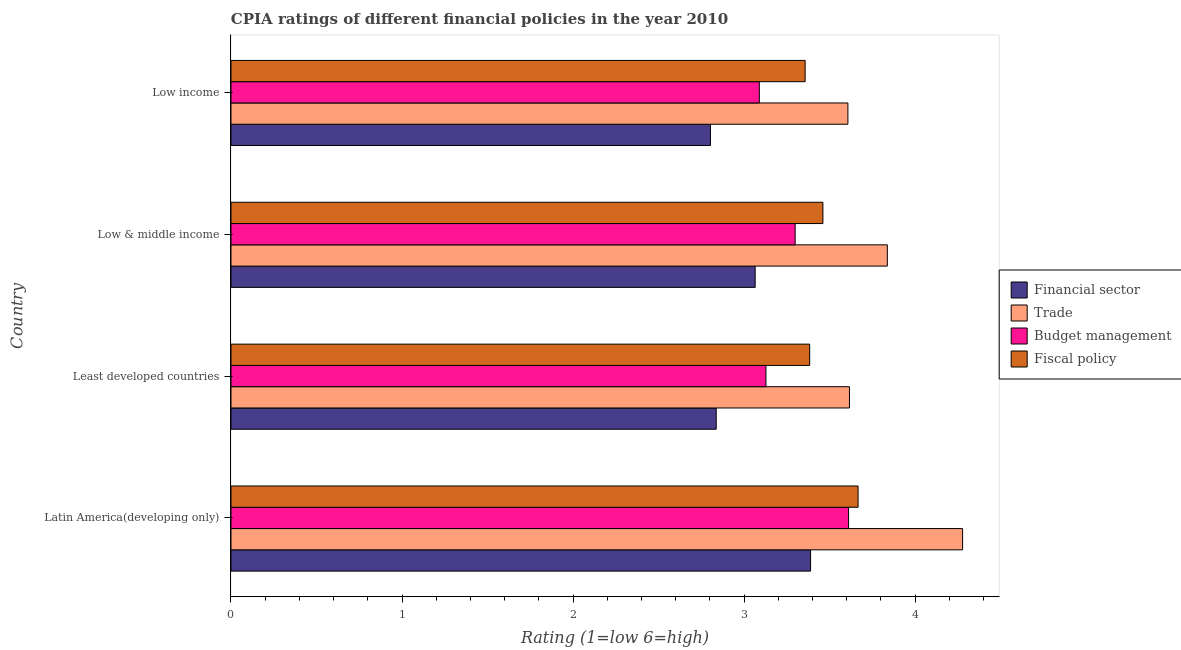How many different coloured bars are there?
Provide a short and direct response. 4. How many groups of bars are there?
Your answer should be compact. 4. Are the number of bars per tick equal to the number of legend labels?
Make the answer very short. Yes. Are the number of bars on each tick of the Y-axis equal?
Offer a very short reply. Yes. How many bars are there on the 4th tick from the bottom?
Provide a short and direct response. 4. What is the label of the 1st group of bars from the top?
Your answer should be compact. Low income. In how many cases, is the number of bars for a given country not equal to the number of legend labels?
Ensure brevity in your answer.  0. What is the cpia rating of trade in Low & middle income?
Your answer should be compact. 3.84. Across all countries, what is the maximum cpia rating of trade?
Your answer should be very brief. 4.28. Across all countries, what is the minimum cpia rating of fiscal policy?
Make the answer very short. 3.36. In which country was the cpia rating of fiscal policy maximum?
Provide a short and direct response. Latin America(developing only). What is the total cpia rating of trade in the graph?
Keep it short and to the point. 15.34. What is the difference between the cpia rating of fiscal policy in Latin America(developing only) and that in Least developed countries?
Give a very brief answer. 0.28. What is the difference between the cpia rating of financial sector in Least developed countries and the cpia rating of budget management in Low income?
Provide a short and direct response. -0.25. What is the average cpia rating of fiscal policy per country?
Give a very brief answer. 3.47. What is the difference between the cpia rating of fiscal policy and cpia rating of budget management in Least developed countries?
Your response must be concise. 0.26. In how many countries, is the cpia rating of fiscal policy greater than 0.2 ?
Keep it short and to the point. 4. What is the ratio of the cpia rating of budget management in Latin America(developing only) to that in Least developed countries?
Provide a succinct answer. 1.15. Is the cpia rating of trade in Least developed countries less than that in Low & middle income?
Make the answer very short. Yes. What is the difference between the highest and the second highest cpia rating of financial sector?
Your answer should be very brief. 0.32. What is the difference between the highest and the lowest cpia rating of financial sector?
Make the answer very short. 0.59. Is the sum of the cpia rating of budget management in Least developed countries and Low income greater than the maximum cpia rating of financial sector across all countries?
Offer a very short reply. Yes. Is it the case that in every country, the sum of the cpia rating of trade and cpia rating of budget management is greater than the sum of cpia rating of financial sector and cpia rating of fiscal policy?
Your answer should be compact. No. What does the 2nd bar from the top in Low income represents?
Your answer should be very brief. Budget management. What does the 4th bar from the bottom in Low income represents?
Provide a succinct answer. Fiscal policy. Is it the case that in every country, the sum of the cpia rating of financial sector and cpia rating of trade is greater than the cpia rating of budget management?
Keep it short and to the point. Yes. Are all the bars in the graph horizontal?
Your response must be concise. Yes. How many countries are there in the graph?
Your answer should be very brief. 4. What is the difference between two consecutive major ticks on the X-axis?
Give a very brief answer. 1. Are the values on the major ticks of X-axis written in scientific E-notation?
Keep it short and to the point. No. Does the graph contain grids?
Provide a short and direct response. No. What is the title of the graph?
Make the answer very short. CPIA ratings of different financial policies in the year 2010. What is the label or title of the Y-axis?
Your answer should be very brief. Country. What is the Rating (1=low 6=high) of Financial sector in Latin America(developing only)?
Your answer should be compact. 3.39. What is the Rating (1=low 6=high) of Trade in Latin America(developing only)?
Your response must be concise. 4.28. What is the Rating (1=low 6=high) of Budget management in Latin America(developing only)?
Offer a terse response. 3.61. What is the Rating (1=low 6=high) in Fiscal policy in Latin America(developing only)?
Your response must be concise. 3.67. What is the Rating (1=low 6=high) in Financial sector in Least developed countries?
Offer a terse response. 2.84. What is the Rating (1=low 6=high) of Trade in Least developed countries?
Give a very brief answer. 3.62. What is the Rating (1=low 6=high) of Budget management in Least developed countries?
Your answer should be very brief. 3.13. What is the Rating (1=low 6=high) in Fiscal policy in Least developed countries?
Give a very brief answer. 3.38. What is the Rating (1=low 6=high) of Financial sector in Low & middle income?
Your response must be concise. 3.06. What is the Rating (1=low 6=high) of Trade in Low & middle income?
Offer a very short reply. 3.84. What is the Rating (1=low 6=high) of Budget management in Low & middle income?
Your response must be concise. 3.3. What is the Rating (1=low 6=high) in Fiscal policy in Low & middle income?
Keep it short and to the point. 3.46. What is the Rating (1=low 6=high) of Financial sector in Low income?
Your response must be concise. 2.8. What is the Rating (1=low 6=high) in Trade in Low income?
Your response must be concise. 3.61. What is the Rating (1=low 6=high) of Budget management in Low income?
Offer a very short reply. 3.09. What is the Rating (1=low 6=high) of Fiscal policy in Low income?
Provide a short and direct response. 3.36. Across all countries, what is the maximum Rating (1=low 6=high) in Financial sector?
Keep it short and to the point. 3.39. Across all countries, what is the maximum Rating (1=low 6=high) of Trade?
Offer a very short reply. 4.28. Across all countries, what is the maximum Rating (1=low 6=high) in Budget management?
Provide a succinct answer. 3.61. Across all countries, what is the maximum Rating (1=low 6=high) in Fiscal policy?
Your response must be concise. 3.67. Across all countries, what is the minimum Rating (1=low 6=high) of Financial sector?
Your response must be concise. 2.8. Across all countries, what is the minimum Rating (1=low 6=high) in Trade?
Your answer should be very brief. 3.61. Across all countries, what is the minimum Rating (1=low 6=high) of Budget management?
Provide a short and direct response. 3.09. Across all countries, what is the minimum Rating (1=low 6=high) of Fiscal policy?
Ensure brevity in your answer.  3.36. What is the total Rating (1=low 6=high) in Financial sector in the graph?
Offer a terse response. 12.09. What is the total Rating (1=low 6=high) in Trade in the graph?
Give a very brief answer. 15.34. What is the total Rating (1=low 6=high) in Budget management in the graph?
Give a very brief answer. 13.13. What is the total Rating (1=low 6=high) in Fiscal policy in the graph?
Your answer should be compact. 13.87. What is the difference between the Rating (1=low 6=high) of Financial sector in Latin America(developing only) and that in Least developed countries?
Ensure brevity in your answer.  0.55. What is the difference between the Rating (1=low 6=high) of Trade in Latin America(developing only) and that in Least developed countries?
Offer a very short reply. 0.66. What is the difference between the Rating (1=low 6=high) in Budget management in Latin America(developing only) and that in Least developed countries?
Provide a succinct answer. 0.48. What is the difference between the Rating (1=low 6=high) of Fiscal policy in Latin America(developing only) and that in Least developed countries?
Your answer should be compact. 0.28. What is the difference between the Rating (1=low 6=high) of Financial sector in Latin America(developing only) and that in Low & middle income?
Your answer should be compact. 0.32. What is the difference between the Rating (1=low 6=high) of Trade in Latin America(developing only) and that in Low & middle income?
Make the answer very short. 0.44. What is the difference between the Rating (1=low 6=high) in Budget management in Latin America(developing only) and that in Low & middle income?
Ensure brevity in your answer.  0.31. What is the difference between the Rating (1=low 6=high) in Fiscal policy in Latin America(developing only) and that in Low & middle income?
Your response must be concise. 0.21. What is the difference between the Rating (1=low 6=high) of Financial sector in Latin America(developing only) and that in Low income?
Offer a terse response. 0.59. What is the difference between the Rating (1=low 6=high) in Trade in Latin America(developing only) and that in Low income?
Your response must be concise. 0.67. What is the difference between the Rating (1=low 6=high) of Budget management in Latin America(developing only) and that in Low income?
Make the answer very short. 0.52. What is the difference between the Rating (1=low 6=high) in Fiscal policy in Latin America(developing only) and that in Low income?
Ensure brevity in your answer.  0.31. What is the difference between the Rating (1=low 6=high) of Financial sector in Least developed countries and that in Low & middle income?
Ensure brevity in your answer.  -0.23. What is the difference between the Rating (1=low 6=high) of Trade in Least developed countries and that in Low & middle income?
Ensure brevity in your answer.  -0.22. What is the difference between the Rating (1=low 6=high) of Budget management in Least developed countries and that in Low & middle income?
Provide a short and direct response. -0.17. What is the difference between the Rating (1=low 6=high) of Fiscal policy in Least developed countries and that in Low & middle income?
Offer a terse response. -0.08. What is the difference between the Rating (1=low 6=high) of Financial sector in Least developed countries and that in Low income?
Offer a very short reply. 0.03. What is the difference between the Rating (1=low 6=high) of Trade in Least developed countries and that in Low income?
Your answer should be compact. 0.01. What is the difference between the Rating (1=low 6=high) of Budget management in Least developed countries and that in Low income?
Offer a terse response. 0.04. What is the difference between the Rating (1=low 6=high) of Fiscal policy in Least developed countries and that in Low income?
Give a very brief answer. 0.03. What is the difference between the Rating (1=low 6=high) of Financial sector in Low & middle income and that in Low income?
Your answer should be very brief. 0.26. What is the difference between the Rating (1=low 6=high) in Trade in Low & middle income and that in Low income?
Keep it short and to the point. 0.23. What is the difference between the Rating (1=low 6=high) of Budget management in Low & middle income and that in Low income?
Provide a short and direct response. 0.21. What is the difference between the Rating (1=low 6=high) in Fiscal policy in Low & middle income and that in Low income?
Keep it short and to the point. 0.1. What is the difference between the Rating (1=low 6=high) in Financial sector in Latin America(developing only) and the Rating (1=low 6=high) in Trade in Least developed countries?
Provide a succinct answer. -0.23. What is the difference between the Rating (1=low 6=high) in Financial sector in Latin America(developing only) and the Rating (1=low 6=high) in Budget management in Least developed countries?
Provide a short and direct response. 0.26. What is the difference between the Rating (1=low 6=high) in Financial sector in Latin America(developing only) and the Rating (1=low 6=high) in Fiscal policy in Least developed countries?
Offer a very short reply. 0.01. What is the difference between the Rating (1=low 6=high) of Trade in Latin America(developing only) and the Rating (1=low 6=high) of Budget management in Least developed countries?
Provide a short and direct response. 1.15. What is the difference between the Rating (1=low 6=high) in Trade in Latin America(developing only) and the Rating (1=low 6=high) in Fiscal policy in Least developed countries?
Offer a terse response. 0.89. What is the difference between the Rating (1=low 6=high) in Budget management in Latin America(developing only) and the Rating (1=low 6=high) in Fiscal policy in Least developed countries?
Keep it short and to the point. 0.23. What is the difference between the Rating (1=low 6=high) of Financial sector in Latin America(developing only) and the Rating (1=low 6=high) of Trade in Low & middle income?
Provide a succinct answer. -0.45. What is the difference between the Rating (1=low 6=high) in Financial sector in Latin America(developing only) and the Rating (1=low 6=high) in Budget management in Low & middle income?
Offer a very short reply. 0.09. What is the difference between the Rating (1=low 6=high) of Financial sector in Latin America(developing only) and the Rating (1=low 6=high) of Fiscal policy in Low & middle income?
Your response must be concise. -0.07. What is the difference between the Rating (1=low 6=high) in Trade in Latin America(developing only) and the Rating (1=low 6=high) in Budget management in Low & middle income?
Make the answer very short. 0.98. What is the difference between the Rating (1=low 6=high) in Trade in Latin America(developing only) and the Rating (1=low 6=high) in Fiscal policy in Low & middle income?
Make the answer very short. 0.82. What is the difference between the Rating (1=low 6=high) in Budget management in Latin America(developing only) and the Rating (1=low 6=high) in Fiscal policy in Low & middle income?
Provide a short and direct response. 0.15. What is the difference between the Rating (1=low 6=high) of Financial sector in Latin America(developing only) and the Rating (1=low 6=high) of Trade in Low income?
Your response must be concise. -0.22. What is the difference between the Rating (1=low 6=high) of Financial sector in Latin America(developing only) and the Rating (1=low 6=high) of Budget management in Low income?
Make the answer very short. 0.3. What is the difference between the Rating (1=low 6=high) of Financial sector in Latin America(developing only) and the Rating (1=low 6=high) of Fiscal policy in Low income?
Your answer should be very brief. 0.03. What is the difference between the Rating (1=low 6=high) of Trade in Latin America(developing only) and the Rating (1=low 6=high) of Budget management in Low income?
Ensure brevity in your answer.  1.19. What is the difference between the Rating (1=low 6=high) in Trade in Latin America(developing only) and the Rating (1=low 6=high) in Fiscal policy in Low income?
Offer a terse response. 0.92. What is the difference between the Rating (1=low 6=high) in Budget management in Latin America(developing only) and the Rating (1=low 6=high) in Fiscal policy in Low income?
Your answer should be compact. 0.25. What is the difference between the Rating (1=low 6=high) in Financial sector in Least developed countries and the Rating (1=low 6=high) in Trade in Low & middle income?
Your response must be concise. -1. What is the difference between the Rating (1=low 6=high) in Financial sector in Least developed countries and the Rating (1=low 6=high) in Budget management in Low & middle income?
Ensure brevity in your answer.  -0.46. What is the difference between the Rating (1=low 6=high) of Financial sector in Least developed countries and the Rating (1=low 6=high) of Fiscal policy in Low & middle income?
Offer a terse response. -0.62. What is the difference between the Rating (1=low 6=high) of Trade in Least developed countries and the Rating (1=low 6=high) of Budget management in Low & middle income?
Offer a very short reply. 0.32. What is the difference between the Rating (1=low 6=high) of Trade in Least developed countries and the Rating (1=low 6=high) of Fiscal policy in Low & middle income?
Give a very brief answer. 0.16. What is the difference between the Rating (1=low 6=high) in Budget management in Least developed countries and the Rating (1=low 6=high) in Fiscal policy in Low & middle income?
Your response must be concise. -0.33. What is the difference between the Rating (1=low 6=high) of Financial sector in Least developed countries and the Rating (1=low 6=high) of Trade in Low income?
Offer a very short reply. -0.77. What is the difference between the Rating (1=low 6=high) in Financial sector in Least developed countries and the Rating (1=low 6=high) in Budget management in Low income?
Offer a very short reply. -0.25. What is the difference between the Rating (1=low 6=high) in Financial sector in Least developed countries and the Rating (1=low 6=high) in Fiscal policy in Low income?
Your answer should be very brief. -0.52. What is the difference between the Rating (1=low 6=high) of Trade in Least developed countries and the Rating (1=low 6=high) of Budget management in Low income?
Provide a short and direct response. 0.53. What is the difference between the Rating (1=low 6=high) in Trade in Least developed countries and the Rating (1=low 6=high) in Fiscal policy in Low income?
Offer a terse response. 0.26. What is the difference between the Rating (1=low 6=high) in Budget management in Least developed countries and the Rating (1=low 6=high) in Fiscal policy in Low income?
Offer a very short reply. -0.23. What is the difference between the Rating (1=low 6=high) in Financial sector in Low & middle income and the Rating (1=low 6=high) in Trade in Low income?
Offer a terse response. -0.54. What is the difference between the Rating (1=low 6=high) in Financial sector in Low & middle income and the Rating (1=low 6=high) in Budget management in Low income?
Your answer should be compact. -0.02. What is the difference between the Rating (1=low 6=high) in Financial sector in Low & middle income and the Rating (1=low 6=high) in Fiscal policy in Low income?
Provide a succinct answer. -0.29. What is the difference between the Rating (1=low 6=high) in Trade in Low & middle income and the Rating (1=low 6=high) in Budget management in Low income?
Ensure brevity in your answer.  0.75. What is the difference between the Rating (1=low 6=high) of Trade in Low & middle income and the Rating (1=low 6=high) of Fiscal policy in Low income?
Give a very brief answer. 0.48. What is the difference between the Rating (1=low 6=high) in Budget management in Low & middle income and the Rating (1=low 6=high) in Fiscal policy in Low income?
Make the answer very short. -0.06. What is the average Rating (1=low 6=high) in Financial sector per country?
Give a very brief answer. 3.02. What is the average Rating (1=low 6=high) of Trade per country?
Your answer should be compact. 3.83. What is the average Rating (1=low 6=high) in Budget management per country?
Your answer should be compact. 3.28. What is the average Rating (1=low 6=high) in Fiscal policy per country?
Keep it short and to the point. 3.47. What is the difference between the Rating (1=low 6=high) in Financial sector and Rating (1=low 6=high) in Trade in Latin America(developing only)?
Your answer should be compact. -0.89. What is the difference between the Rating (1=low 6=high) in Financial sector and Rating (1=low 6=high) in Budget management in Latin America(developing only)?
Make the answer very short. -0.22. What is the difference between the Rating (1=low 6=high) of Financial sector and Rating (1=low 6=high) of Fiscal policy in Latin America(developing only)?
Offer a very short reply. -0.28. What is the difference between the Rating (1=low 6=high) of Trade and Rating (1=low 6=high) of Budget management in Latin America(developing only)?
Give a very brief answer. 0.67. What is the difference between the Rating (1=low 6=high) of Trade and Rating (1=low 6=high) of Fiscal policy in Latin America(developing only)?
Your answer should be very brief. 0.61. What is the difference between the Rating (1=low 6=high) in Budget management and Rating (1=low 6=high) in Fiscal policy in Latin America(developing only)?
Your answer should be compact. -0.06. What is the difference between the Rating (1=low 6=high) in Financial sector and Rating (1=low 6=high) in Trade in Least developed countries?
Make the answer very short. -0.78. What is the difference between the Rating (1=low 6=high) in Financial sector and Rating (1=low 6=high) in Budget management in Least developed countries?
Offer a terse response. -0.29. What is the difference between the Rating (1=low 6=high) in Financial sector and Rating (1=low 6=high) in Fiscal policy in Least developed countries?
Offer a very short reply. -0.55. What is the difference between the Rating (1=low 6=high) of Trade and Rating (1=low 6=high) of Budget management in Least developed countries?
Your answer should be compact. 0.49. What is the difference between the Rating (1=low 6=high) of Trade and Rating (1=low 6=high) of Fiscal policy in Least developed countries?
Ensure brevity in your answer.  0.23. What is the difference between the Rating (1=low 6=high) of Budget management and Rating (1=low 6=high) of Fiscal policy in Least developed countries?
Your answer should be compact. -0.26. What is the difference between the Rating (1=low 6=high) in Financial sector and Rating (1=low 6=high) in Trade in Low & middle income?
Offer a very short reply. -0.77. What is the difference between the Rating (1=low 6=high) in Financial sector and Rating (1=low 6=high) in Budget management in Low & middle income?
Offer a very short reply. -0.23. What is the difference between the Rating (1=low 6=high) of Financial sector and Rating (1=low 6=high) of Fiscal policy in Low & middle income?
Give a very brief answer. -0.4. What is the difference between the Rating (1=low 6=high) in Trade and Rating (1=low 6=high) in Budget management in Low & middle income?
Provide a short and direct response. 0.54. What is the difference between the Rating (1=low 6=high) of Trade and Rating (1=low 6=high) of Fiscal policy in Low & middle income?
Provide a succinct answer. 0.38. What is the difference between the Rating (1=low 6=high) in Budget management and Rating (1=low 6=high) in Fiscal policy in Low & middle income?
Your answer should be very brief. -0.16. What is the difference between the Rating (1=low 6=high) in Financial sector and Rating (1=low 6=high) in Trade in Low income?
Ensure brevity in your answer.  -0.8. What is the difference between the Rating (1=low 6=high) in Financial sector and Rating (1=low 6=high) in Budget management in Low income?
Offer a very short reply. -0.29. What is the difference between the Rating (1=low 6=high) in Financial sector and Rating (1=low 6=high) in Fiscal policy in Low income?
Give a very brief answer. -0.55. What is the difference between the Rating (1=low 6=high) of Trade and Rating (1=low 6=high) of Budget management in Low income?
Give a very brief answer. 0.52. What is the difference between the Rating (1=low 6=high) in Trade and Rating (1=low 6=high) in Fiscal policy in Low income?
Ensure brevity in your answer.  0.25. What is the difference between the Rating (1=low 6=high) of Budget management and Rating (1=low 6=high) of Fiscal policy in Low income?
Your response must be concise. -0.27. What is the ratio of the Rating (1=low 6=high) of Financial sector in Latin America(developing only) to that in Least developed countries?
Your response must be concise. 1.19. What is the ratio of the Rating (1=low 6=high) in Trade in Latin America(developing only) to that in Least developed countries?
Ensure brevity in your answer.  1.18. What is the ratio of the Rating (1=low 6=high) of Budget management in Latin America(developing only) to that in Least developed countries?
Your response must be concise. 1.15. What is the ratio of the Rating (1=low 6=high) in Fiscal policy in Latin America(developing only) to that in Least developed countries?
Make the answer very short. 1.08. What is the ratio of the Rating (1=low 6=high) of Financial sector in Latin America(developing only) to that in Low & middle income?
Give a very brief answer. 1.11. What is the ratio of the Rating (1=low 6=high) in Trade in Latin America(developing only) to that in Low & middle income?
Provide a succinct answer. 1.11. What is the ratio of the Rating (1=low 6=high) of Budget management in Latin America(developing only) to that in Low & middle income?
Your answer should be very brief. 1.09. What is the ratio of the Rating (1=low 6=high) in Fiscal policy in Latin America(developing only) to that in Low & middle income?
Your answer should be compact. 1.06. What is the ratio of the Rating (1=low 6=high) of Financial sector in Latin America(developing only) to that in Low income?
Keep it short and to the point. 1.21. What is the ratio of the Rating (1=low 6=high) of Trade in Latin America(developing only) to that in Low income?
Make the answer very short. 1.19. What is the ratio of the Rating (1=low 6=high) in Budget management in Latin America(developing only) to that in Low income?
Offer a terse response. 1.17. What is the ratio of the Rating (1=low 6=high) of Fiscal policy in Latin America(developing only) to that in Low income?
Offer a very short reply. 1.09. What is the ratio of the Rating (1=low 6=high) in Financial sector in Least developed countries to that in Low & middle income?
Give a very brief answer. 0.93. What is the ratio of the Rating (1=low 6=high) of Trade in Least developed countries to that in Low & middle income?
Offer a terse response. 0.94. What is the ratio of the Rating (1=low 6=high) of Budget management in Least developed countries to that in Low & middle income?
Give a very brief answer. 0.95. What is the ratio of the Rating (1=low 6=high) in Fiscal policy in Least developed countries to that in Low & middle income?
Make the answer very short. 0.98. What is the ratio of the Rating (1=low 6=high) of Financial sector in Least developed countries to that in Low income?
Your answer should be compact. 1.01. What is the ratio of the Rating (1=low 6=high) of Trade in Least developed countries to that in Low income?
Offer a very short reply. 1. What is the ratio of the Rating (1=low 6=high) of Budget management in Least developed countries to that in Low income?
Your response must be concise. 1.01. What is the ratio of the Rating (1=low 6=high) in Fiscal policy in Least developed countries to that in Low income?
Provide a succinct answer. 1.01. What is the ratio of the Rating (1=low 6=high) in Financial sector in Low & middle income to that in Low income?
Offer a very short reply. 1.09. What is the ratio of the Rating (1=low 6=high) of Trade in Low & middle income to that in Low income?
Offer a very short reply. 1.06. What is the ratio of the Rating (1=low 6=high) in Budget management in Low & middle income to that in Low income?
Provide a short and direct response. 1.07. What is the ratio of the Rating (1=low 6=high) in Fiscal policy in Low & middle income to that in Low income?
Your answer should be very brief. 1.03. What is the difference between the highest and the second highest Rating (1=low 6=high) in Financial sector?
Your answer should be very brief. 0.32. What is the difference between the highest and the second highest Rating (1=low 6=high) in Trade?
Provide a short and direct response. 0.44. What is the difference between the highest and the second highest Rating (1=low 6=high) in Budget management?
Make the answer very short. 0.31. What is the difference between the highest and the second highest Rating (1=low 6=high) in Fiscal policy?
Provide a short and direct response. 0.21. What is the difference between the highest and the lowest Rating (1=low 6=high) of Financial sector?
Offer a very short reply. 0.59. What is the difference between the highest and the lowest Rating (1=low 6=high) of Trade?
Ensure brevity in your answer.  0.67. What is the difference between the highest and the lowest Rating (1=low 6=high) in Budget management?
Your answer should be very brief. 0.52. What is the difference between the highest and the lowest Rating (1=low 6=high) in Fiscal policy?
Provide a succinct answer. 0.31. 